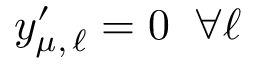<formula> <loc_0><loc_0><loc_500><loc_500>y _ { \mu , \, \ell } ^ { \prime } = 0 \, \forall \ell</formula> 